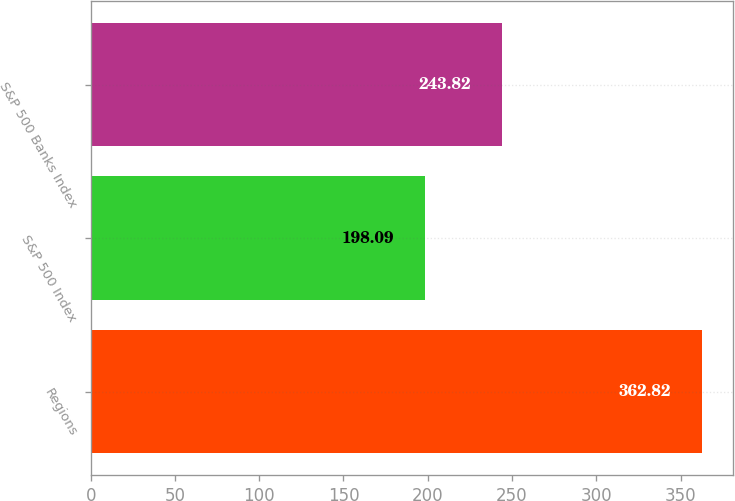Convert chart. <chart><loc_0><loc_0><loc_500><loc_500><bar_chart><fcel>Regions<fcel>S&P 500 Index<fcel>S&P 500 Banks Index<nl><fcel>362.82<fcel>198.09<fcel>243.82<nl></chart> 